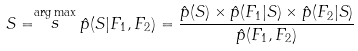<formula> <loc_0><loc_0><loc_500><loc_500>S = \stackrel { \arg \max } { s } \hat { p } ( S | F _ { 1 } , F _ { 2 } ) = \frac { \hat { p } ( S ) \times \hat { p } ( F _ { 1 } | S ) \times \hat { p } ( F _ { 2 } | S ) } { \hat { p } ( F _ { 1 } , F _ { 2 } ) }</formula> 